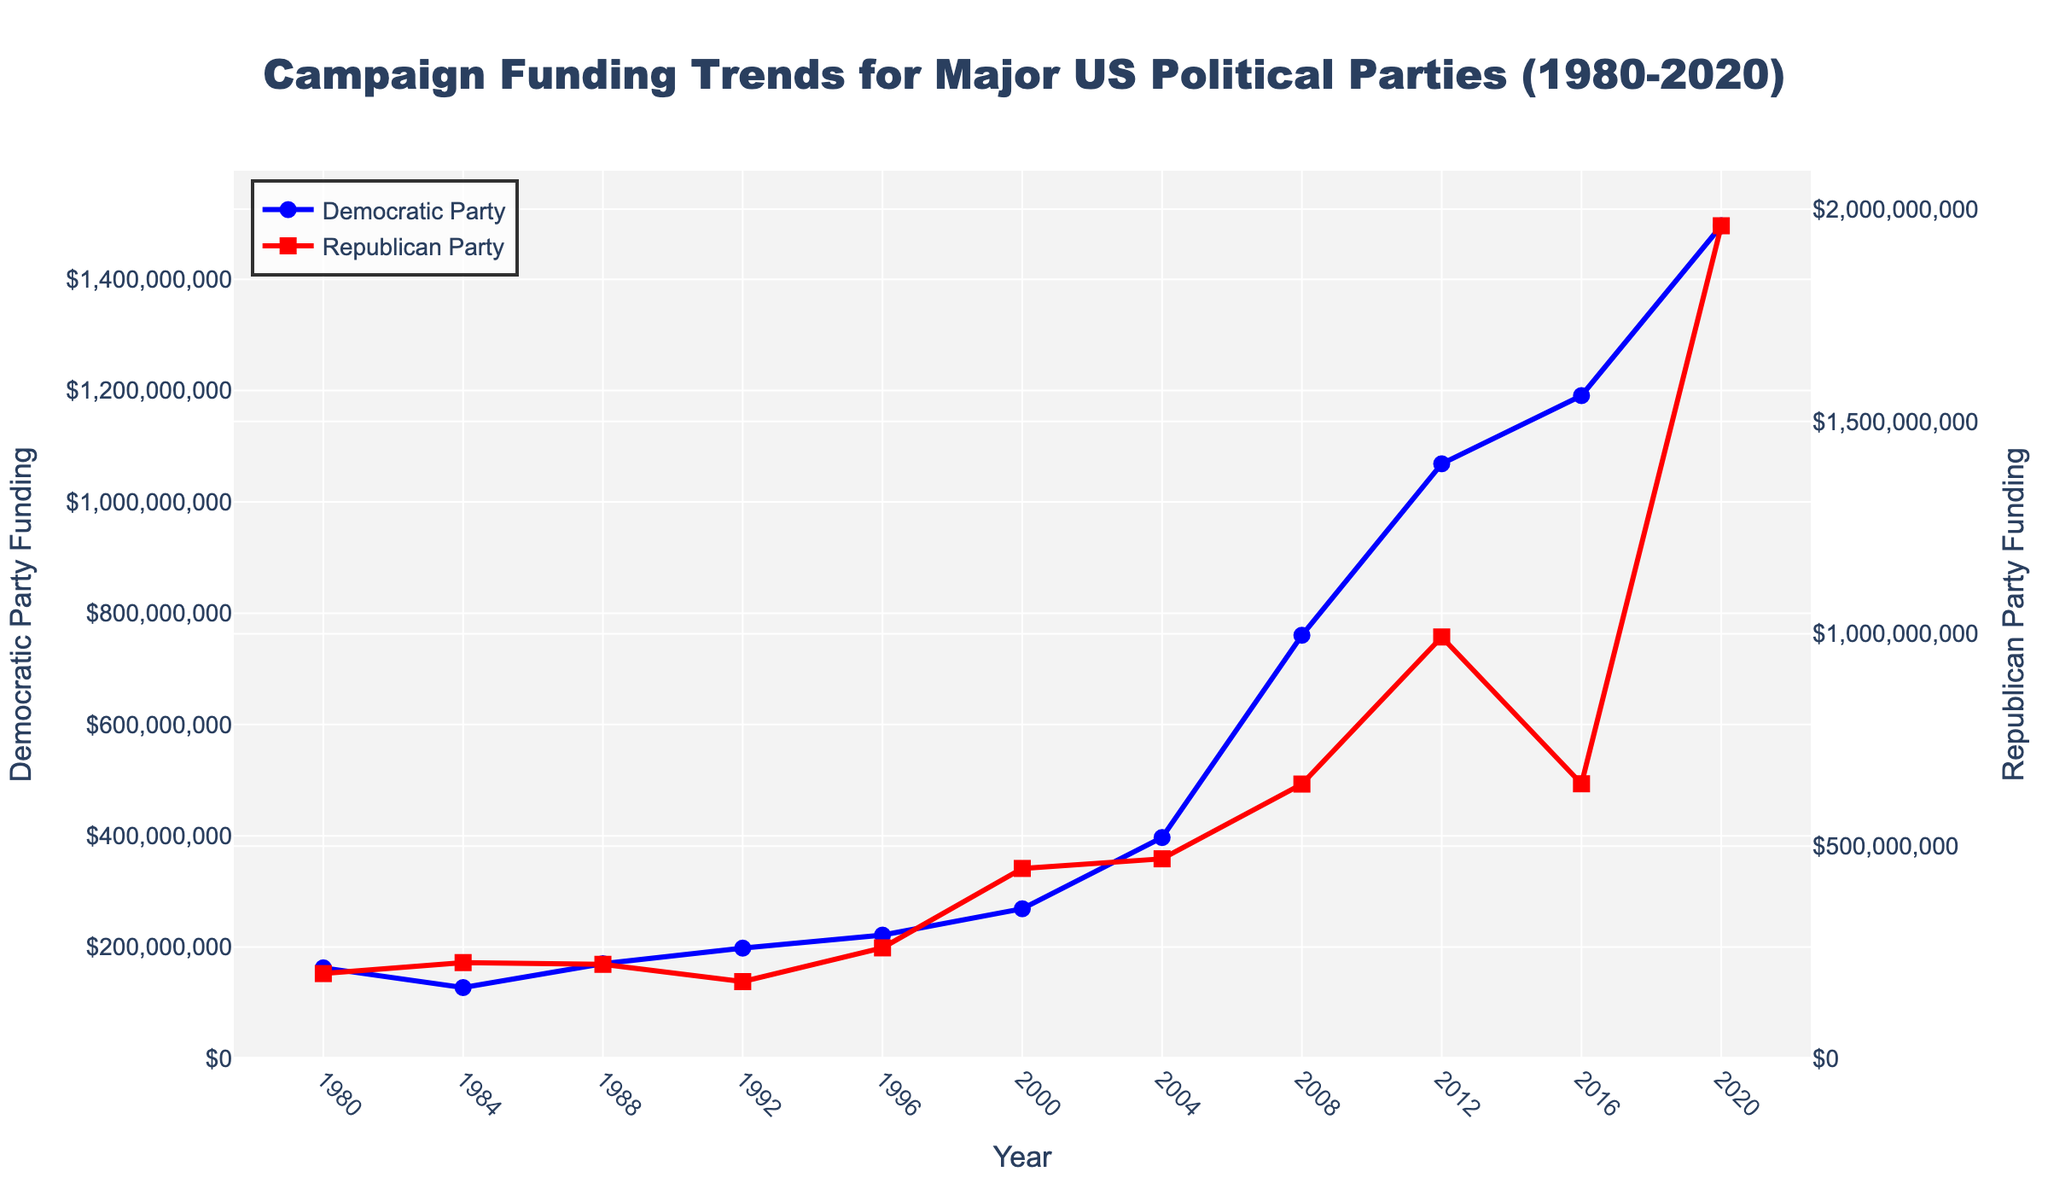What is the highest campaign funding received by the Democratic Party in this period? The highest funding can be observed at the peak of the Democratic Party's line on the graph. It's around the year 2020 and corresponds to the highest point on the blue line.
Answer: 1496200000 How did the Republican Party's funding in 2008 compare to the Democratic Party's funding the same year? In 2008, the Republican Party's funding is represented by the red line and marked with a square. Compare this value visually to the Democratic Party's blue line. Both values are available in the figure, and it shows the Democratic Party's funding was higher than the Republican Party's in 2008.
Answer: Democratic Party's funding was higher What is the average campaign funding for both parties from 1980 to 2020? First, sum all the campaign funding values for both parties over the years. Then, divide the total funding by the number of years (11). (Sum(Democratic Party + Republican Party) / 11 years). This involves adding all funding values from both parties and then averaging.
Answer: Approx. 621409090.91 Between which years did the Democratic Party see the most significant increase in funding? Look for the steepest upward trend in the blue line. This indicates the period with the greatest increase. It is between 2004 and 2008.
Answer: 2004 to 2008 Did the Republican Party ever receive more funding than the Democratic Party between 1980 and 2020? Visually compare the blue and red lines throughout the graph. Yes, there are multiple years where the red line (Republican) is above the blue line (Democratic), such as in 1984, 1996, 2000, 2004, and 2020.
Answer: Yes What was the difference in campaign funding between the Republican and Democratic Parties in 2020? Identify the funding amounts for both parties in 2020. Subtract the Democratic Party’s funding from the Republican Party’s funding in 2020 (1960800000 - 1496200000).
Answer: 464600000 Which party had more funding consistently from 1980 to 1992? Compare the position of the blue (Democratic) and red (Republican) lines for each year from 1980 to 1992. The red line is generally higher than the blue line during these years, meaning the Republican Party had more funding consistently.
Answer: Republican Party Which year saw the steepest decline in the Republican Party's funding? Identify the year where the red line shows the sharpest downward slope. This decline is most noticeable between 2016 and 2020.
Answer: 2016 to 2020 What is the yearly average increase in Democratic Party funding from 1980 to 2020? Calculate the increase for each year, sum these increases, and then divide by the number of periods (which is 10, as there are 11 years). This involves taking the differences year-over-year and averaging them.
Answer: Approx. 107037636.36 